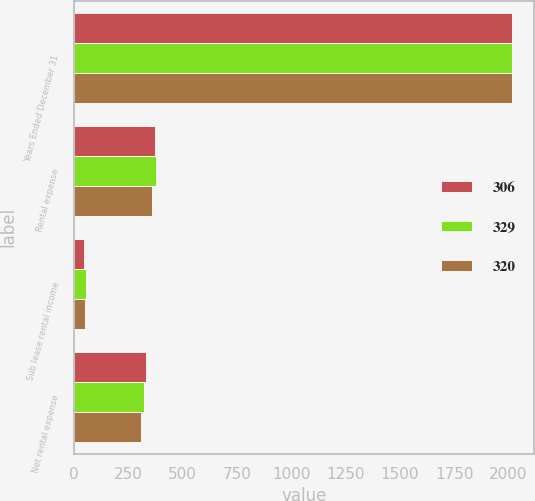Convert chart to OTSL. <chart><loc_0><loc_0><loc_500><loc_500><stacked_bar_chart><ecel><fcel>Years Ended December 31<fcel>Rental expense<fcel>Sub lease rental income<fcel>Net rental expense<nl><fcel>306<fcel>2018<fcel>374<fcel>45<fcel>329<nl><fcel>329<fcel>2017<fcel>377<fcel>57<fcel>320<nl><fcel>320<fcel>2016<fcel>358<fcel>52<fcel>306<nl></chart> 